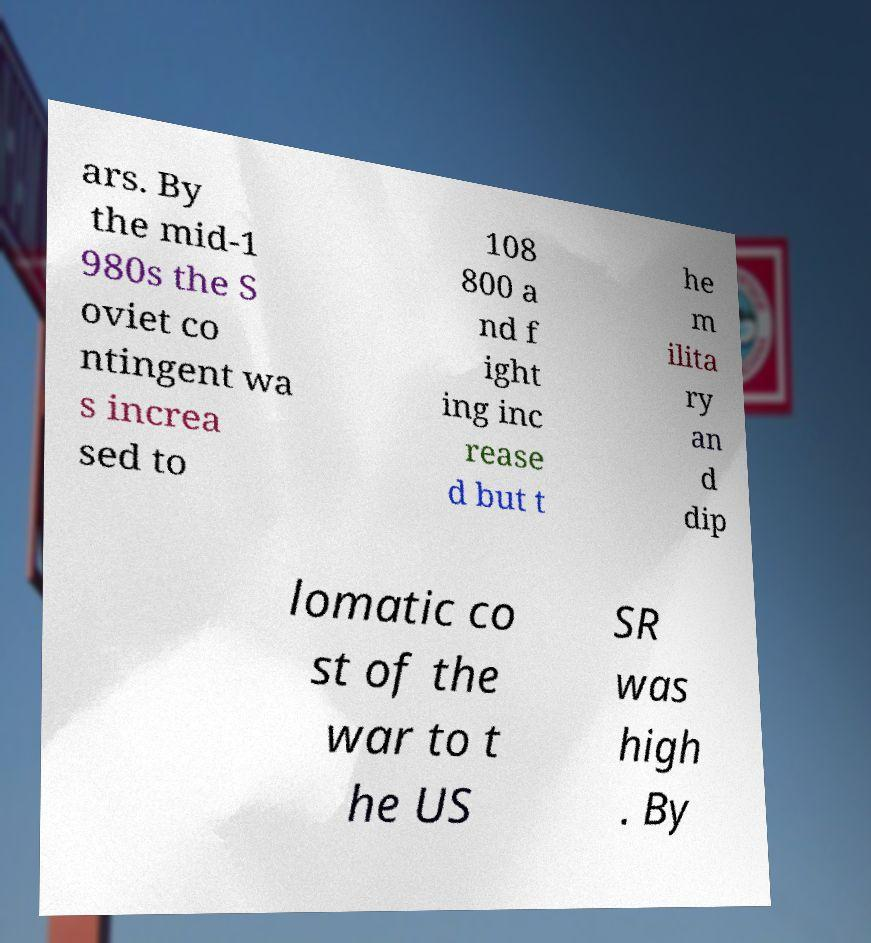I need the written content from this picture converted into text. Can you do that? ars. By the mid-1 980s the S oviet co ntingent wa s increa sed to 108 800 a nd f ight ing inc rease d but t he m ilita ry an d dip lomatic co st of the war to t he US SR was high . By 